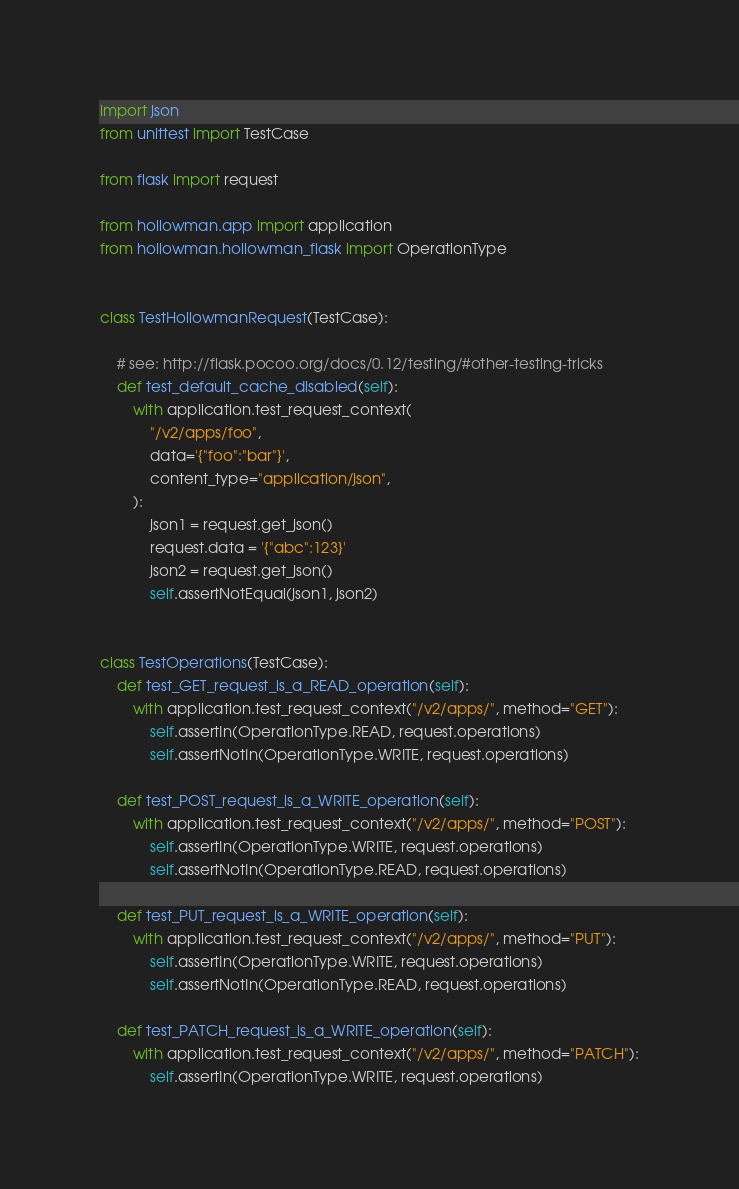<code> <loc_0><loc_0><loc_500><loc_500><_Python_>import json
from unittest import TestCase

from flask import request

from hollowman.app import application
from hollowman.hollowman_flask import OperationType


class TestHollowmanRequest(TestCase):

    # see: http://flask.pocoo.org/docs/0.12/testing/#other-testing-tricks
    def test_default_cache_disabled(self):
        with application.test_request_context(
            "/v2/apps/foo",
            data='{"foo":"bar"}',
            content_type="application/json",
        ):
            json1 = request.get_json()
            request.data = '{"abc":123}'
            json2 = request.get_json()
            self.assertNotEqual(json1, json2)


class TestOperations(TestCase):
    def test_GET_request_is_a_READ_operation(self):
        with application.test_request_context("/v2/apps/", method="GET"):
            self.assertIn(OperationType.READ, request.operations)
            self.assertNotIn(OperationType.WRITE, request.operations)

    def test_POST_request_is_a_WRITE_operation(self):
        with application.test_request_context("/v2/apps/", method="POST"):
            self.assertIn(OperationType.WRITE, request.operations)
            self.assertNotIn(OperationType.READ, request.operations)

    def test_PUT_request_is_a_WRITE_operation(self):
        with application.test_request_context("/v2/apps/", method="PUT"):
            self.assertIn(OperationType.WRITE, request.operations)
            self.assertNotIn(OperationType.READ, request.operations)

    def test_PATCH_request_is_a_WRITE_operation(self):
        with application.test_request_context("/v2/apps/", method="PATCH"):
            self.assertIn(OperationType.WRITE, request.operations)</code> 